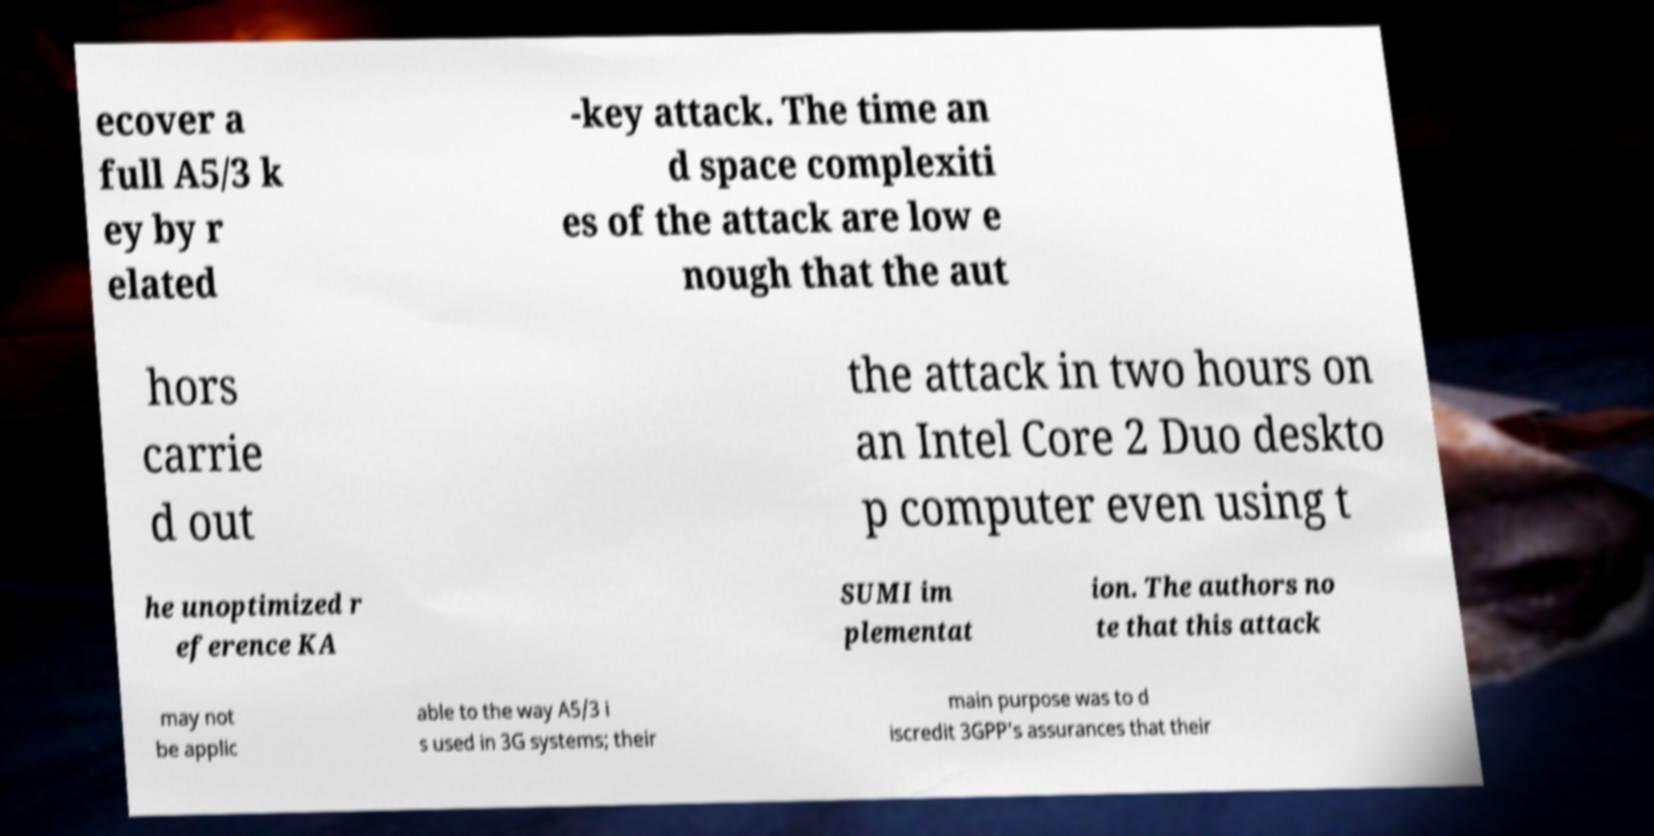What messages or text are displayed in this image? I need them in a readable, typed format. ecover a full A5/3 k ey by r elated -key attack. The time an d space complexiti es of the attack are low e nough that the aut hors carrie d out the attack in two hours on an Intel Core 2 Duo deskto p computer even using t he unoptimized r eference KA SUMI im plementat ion. The authors no te that this attack may not be applic able to the way A5/3 i s used in 3G systems; their main purpose was to d iscredit 3GPP's assurances that their 